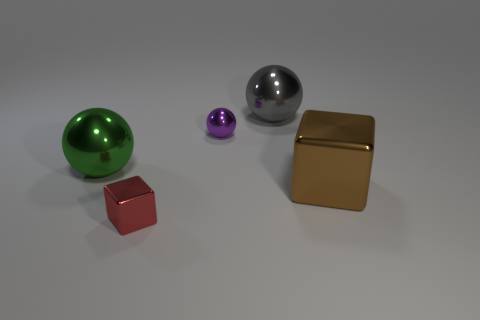There is a tiny thing behind the large thing left of the red thing; what color is it? The small object located behind the larger one, to the left of the red cube, is indeed purple. Its diminutive size contrasts with the other objects, yet its rich purple hue makes it noteworthy amidst the collection. 